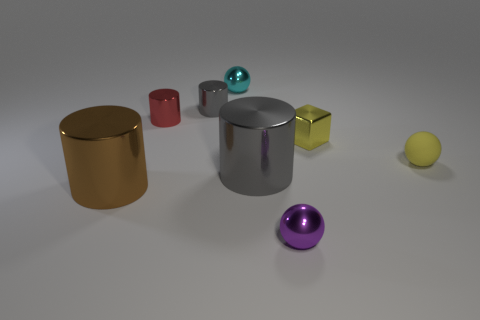Add 1 large blue shiny balls. How many objects exist? 9 Subtract all spheres. How many objects are left? 5 Subtract all purple things. Subtract all matte objects. How many objects are left? 6 Add 5 yellow spheres. How many yellow spheres are left? 6 Add 1 gray things. How many gray things exist? 3 Subtract 1 red cylinders. How many objects are left? 7 